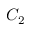<formula> <loc_0><loc_0><loc_500><loc_500>C _ { 2 }</formula> 